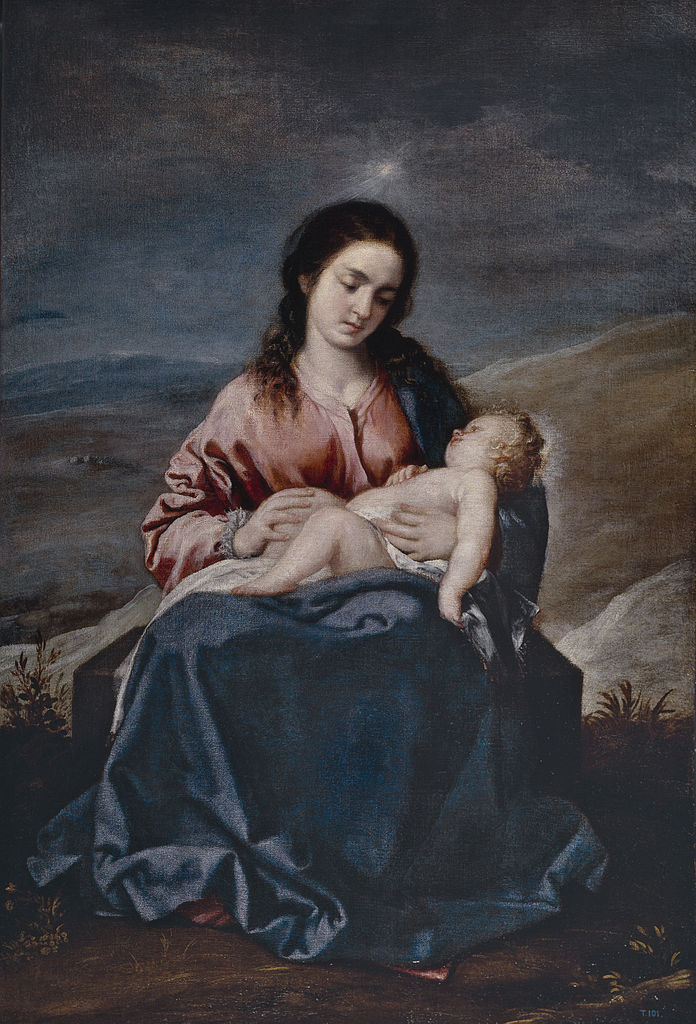Can you tell me more about the possible artistic techniques used in this painting? The painting showcases a meticulous blend of artistic techniques typical of the Baroque period. One prominent technique is chiaroscuro, the strong contrast between light and dark areas, which enhances the three-dimensional effect and guides your eye towards the central figures. The delicate use of sfumato might also be observed in the soft transitions of color and light, giving the painting a hazy, ethereal quality. The clothing and the surrounding textures are rendered with precision through fine brushwork, making the fabric appear tactile and realistic. The background employs atmospheric perspective, where the details become hazier and less distinct as they recede into the distance, creating a sense of depth. The painter's skillful manipulation of these techniques culminates in a scene that is both grounded in realism and elevated by an almost divine luminosity. What emotions do you think the artist aimed to evoke in the viewers? The artist likely sought to evoke a profound sense of reverence and serenity in the viewers. The tender relationship between the woman and the baby, highlighted by their gentle expressions and soft, embracing posture, conveys themes of maternal love and sacred tranquility. The dark, stormy sky juxtaposed with the illuminated figures creates a dramatic backdrop that emphasizes the sanctity and importance of the moment being depicted. These elements work together to instill an emotional response that blends awe, peace, and spiritual contemplation, encouraging viewers to reflect on themes of divine love and protection. 